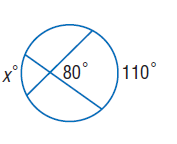Answer the mathemtical geometry problem and directly provide the correct option letter.
Question: Find x. Assume that segments that appear to be tangent are tangent.
Choices: A: 50 B: 75 C: 80 D: 110 A 